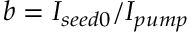<formula> <loc_0><loc_0><loc_500><loc_500>b = I _ { s e e d 0 } / I _ { p u m p }</formula> 